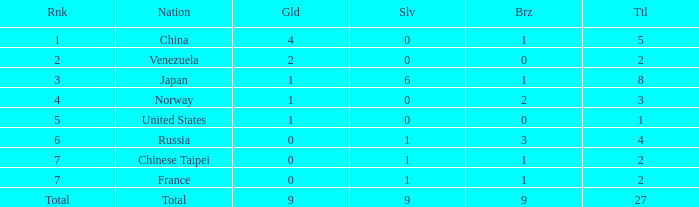What is the sum of Total when rank is 2? 2.0. 